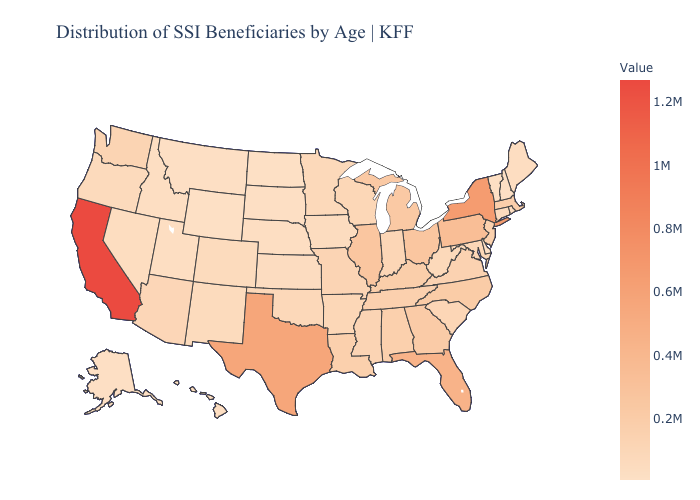Among the states that border Indiana , does Illinois have the highest value?
Write a very short answer. Yes. Among the states that border Tennessee , does Georgia have the highest value?
Short answer required. Yes. Does Pennsylvania have the highest value in the Northeast?
Answer briefly. No. Does Illinois have the highest value in the MidWest?
Give a very brief answer. Yes. Among the states that border North Dakota , does South Dakota have the lowest value?
Concise answer only. Yes. 